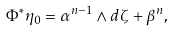Convert formula to latex. <formula><loc_0><loc_0><loc_500><loc_500>\Phi ^ { * } \eta _ { 0 } = \alpha ^ { n - 1 } \wedge d \zeta + \beta ^ { n } ,</formula> 